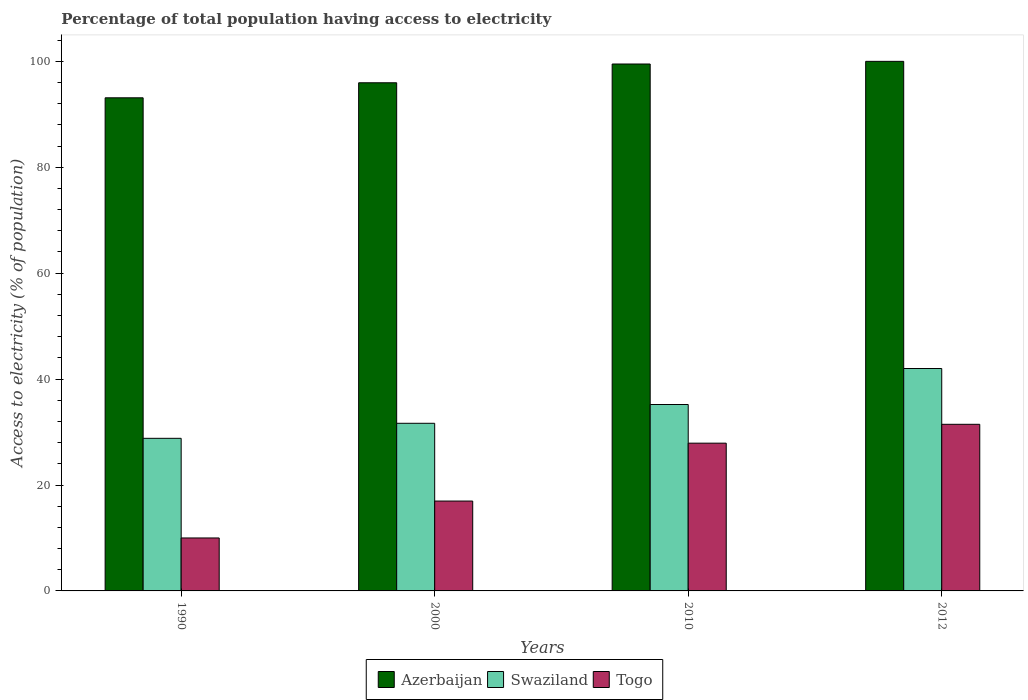How many different coloured bars are there?
Make the answer very short. 3. Are the number of bars on each tick of the X-axis equal?
Offer a terse response. Yes. How many bars are there on the 2nd tick from the right?
Provide a succinct answer. 3. What is the percentage of population that have access to electricity in Swaziland in 1990?
Your response must be concise. 28.82. In which year was the percentage of population that have access to electricity in Swaziland maximum?
Your response must be concise. 2012. What is the total percentage of population that have access to electricity in Azerbaijan in the graph?
Keep it short and to the point. 388.57. What is the difference between the percentage of population that have access to electricity in Swaziland in 1990 and that in 2000?
Make the answer very short. -2.84. What is the difference between the percentage of population that have access to electricity in Azerbaijan in 2012 and the percentage of population that have access to electricity in Swaziland in 1990?
Your response must be concise. 71.18. What is the average percentage of population that have access to electricity in Azerbaijan per year?
Keep it short and to the point. 97.14. In the year 2010, what is the difference between the percentage of population that have access to electricity in Togo and percentage of population that have access to electricity in Swaziland?
Provide a short and direct response. -7.3. What is the ratio of the percentage of population that have access to electricity in Azerbaijan in 1990 to that in 2010?
Your answer should be very brief. 0.94. What is the difference between the highest and the second highest percentage of population that have access to electricity in Swaziland?
Make the answer very short. 6.8. What is the difference between the highest and the lowest percentage of population that have access to electricity in Swaziland?
Offer a very short reply. 13.18. What does the 1st bar from the left in 1990 represents?
Provide a succinct answer. Azerbaijan. What does the 2nd bar from the right in 2010 represents?
Ensure brevity in your answer.  Swaziland. How many years are there in the graph?
Provide a succinct answer. 4. What is the difference between two consecutive major ticks on the Y-axis?
Your answer should be compact. 20. Are the values on the major ticks of Y-axis written in scientific E-notation?
Give a very brief answer. No. Does the graph contain grids?
Your answer should be very brief. No. How many legend labels are there?
Ensure brevity in your answer.  3. What is the title of the graph?
Give a very brief answer. Percentage of total population having access to electricity. What is the label or title of the Y-axis?
Ensure brevity in your answer.  Access to electricity (% of population). What is the Access to electricity (% of population) of Azerbaijan in 1990?
Provide a short and direct response. 93.12. What is the Access to electricity (% of population) in Swaziland in 1990?
Offer a very short reply. 28.82. What is the Access to electricity (% of population) in Togo in 1990?
Offer a very short reply. 10. What is the Access to electricity (% of population) of Azerbaijan in 2000?
Give a very brief answer. 95.96. What is the Access to electricity (% of population) of Swaziland in 2000?
Keep it short and to the point. 31.66. What is the Access to electricity (% of population) in Togo in 2000?
Ensure brevity in your answer.  16.97. What is the Access to electricity (% of population) of Azerbaijan in 2010?
Provide a succinct answer. 99.5. What is the Access to electricity (% of population) in Swaziland in 2010?
Provide a succinct answer. 35.2. What is the Access to electricity (% of population) in Togo in 2010?
Provide a short and direct response. 27.9. What is the Access to electricity (% of population) in Togo in 2012?
Provide a short and direct response. 31.46. Across all years, what is the maximum Access to electricity (% of population) in Swaziland?
Your answer should be compact. 42. Across all years, what is the maximum Access to electricity (% of population) of Togo?
Your answer should be very brief. 31.46. Across all years, what is the minimum Access to electricity (% of population) of Azerbaijan?
Ensure brevity in your answer.  93.12. Across all years, what is the minimum Access to electricity (% of population) in Swaziland?
Offer a very short reply. 28.82. Across all years, what is the minimum Access to electricity (% of population) of Togo?
Provide a succinct answer. 10. What is the total Access to electricity (% of population) of Azerbaijan in the graph?
Ensure brevity in your answer.  388.57. What is the total Access to electricity (% of population) in Swaziland in the graph?
Give a very brief answer. 137.67. What is the total Access to electricity (% of population) of Togo in the graph?
Make the answer very short. 86.33. What is the difference between the Access to electricity (% of population) of Azerbaijan in 1990 and that in 2000?
Your answer should be very brief. -2.84. What is the difference between the Access to electricity (% of population) in Swaziland in 1990 and that in 2000?
Keep it short and to the point. -2.84. What is the difference between the Access to electricity (% of population) in Togo in 1990 and that in 2000?
Your answer should be compact. -6.97. What is the difference between the Access to electricity (% of population) of Azerbaijan in 1990 and that in 2010?
Provide a succinct answer. -6.38. What is the difference between the Access to electricity (% of population) of Swaziland in 1990 and that in 2010?
Keep it short and to the point. -6.38. What is the difference between the Access to electricity (% of population) of Togo in 1990 and that in 2010?
Your answer should be compact. -17.9. What is the difference between the Access to electricity (% of population) in Azerbaijan in 1990 and that in 2012?
Your response must be concise. -6.88. What is the difference between the Access to electricity (% of population) of Swaziland in 1990 and that in 2012?
Provide a succinct answer. -13.18. What is the difference between the Access to electricity (% of population) in Togo in 1990 and that in 2012?
Provide a succinct answer. -21.46. What is the difference between the Access to electricity (% of population) of Azerbaijan in 2000 and that in 2010?
Offer a very short reply. -3.54. What is the difference between the Access to electricity (% of population) in Swaziland in 2000 and that in 2010?
Make the answer very short. -3.54. What is the difference between the Access to electricity (% of population) of Togo in 2000 and that in 2010?
Your answer should be compact. -10.93. What is the difference between the Access to electricity (% of population) in Azerbaijan in 2000 and that in 2012?
Your answer should be very brief. -4.04. What is the difference between the Access to electricity (% of population) of Swaziland in 2000 and that in 2012?
Ensure brevity in your answer.  -10.34. What is the difference between the Access to electricity (% of population) of Togo in 2000 and that in 2012?
Offer a terse response. -14.49. What is the difference between the Access to electricity (% of population) in Togo in 2010 and that in 2012?
Offer a terse response. -3.56. What is the difference between the Access to electricity (% of population) in Azerbaijan in 1990 and the Access to electricity (% of population) in Swaziland in 2000?
Ensure brevity in your answer.  61.46. What is the difference between the Access to electricity (% of population) in Azerbaijan in 1990 and the Access to electricity (% of population) in Togo in 2000?
Ensure brevity in your answer.  76.15. What is the difference between the Access to electricity (% of population) of Swaziland in 1990 and the Access to electricity (% of population) of Togo in 2000?
Make the answer very short. 11.85. What is the difference between the Access to electricity (% of population) of Azerbaijan in 1990 and the Access to electricity (% of population) of Swaziland in 2010?
Offer a terse response. 57.92. What is the difference between the Access to electricity (% of population) of Azerbaijan in 1990 and the Access to electricity (% of population) of Togo in 2010?
Your answer should be very brief. 65.22. What is the difference between the Access to electricity (% of population) in Swaziland in 1990 and the Access to electricity (% of population) in Togo in 2010?
Give a very brief answer. 0.92. What is the difference between the Access to electricity (% of population) in Azerbaijan in 1990 and the Access to electricity (% of population) in Swaziland in 2012?
Provide a succinct answer. 51.12. What is the difference between the Access to electricity (% of population) of Azerbaijan in 1990 and the Access to electricity (% of population) of Togo in 2012?
Give a very brief answer. 61.65. What is the difference between the Access to electricity (% of population) of Swaziland in 1990 and the Access to electricity (% of population) of Togo in 2012?
Give a very brief answer. -2.65. What is the difference between the Access to electricity (% of population) of Azerbaijan in 2000 and the Access to electricity (% of population) of Swaziland in 2010?
Keep it short and to the point. 60.76. What is the difference between the Access to electricity (% of population) of Azerbaijan in 2000 and the Access to electricity (% of population) of Togo in 2010?
Your response must be concise. 68.06. What is the difference between the Access to electricity (% of population) of Swaziland in 2000 and the Access to electricity (% of population) of Togo in 2010?
Provide a short and direct response. 3.76. What is the difference between the Access to electricity (% of population) in Azerbaijan in 2000 and the Access to electricity (% of population) in Swaziland in 2012?
Ensure brevity in your answer.  53.96. What is the difference between the Access to electricity (% of population) of Azerbaijan in 2000 and the Access to electricity (% of population) of Togo in 2012?
Ensure brevity in your answer.  64.49. What is the difference between the Access to electricity (% of population) of Swaziland in 2000 and the Access to electricity (% of population) of Togo in 2012?
Keep it short and to the point. 0.19. What is the difference between the Access to electricity (% of population) of Azerbaijan in 2010 and the Access to electricity (% of population) of Swaziland in 2012?
Offer a terse response. 57.5. What is the difference between the Access to electricity (% of population) of Azerbaijan in 2010 and the Access to electricity (% of population) of Togo in 2012?
Provide a succinct answer. 68.04. What is the difference between the Access to electricity (% of population) of Swaziland in 2010 and the Access to electricity (% of population) of Togo in 2012?
Keep it short and to the point. 3.74. What is the average Access to electricity (% of population) of Azerbaijan per year?
Offer a terse response. 97.14. What is the average Access to electricity (% of population) in Swaziland per year?
Ensure brevity in your answer.  34.42. What is the average Access to electricity (% of population) in Togo per year?
Provide a succinct answer. 21.58. In the year 1990, what is the difference between the Access to electricity (% of population) of Azerbaijan and Access to electricity (% of population) of Swaziland?
Keep it short and to the point. 64.3. In the year 1990, what is the difference between the Access to electricity (% of population) of Azerbaijan and Access to electricity (% of population) of Togo?
Give a very brief answer. 83.12. In the year 1990, what is the difference between the Access to electricity (% of population) in Swaziland and Access to electricity (% of population) in Togo?
Your response must be concise. 18.82. In the year 2000, what is the difference between the Access to electricity (% of population) in Azerbaijan and Access to electricity (% of population) in Swaziland?
Your response must be concise. 64.3. In the year 2000, what is the difference between the Access to electricity (% of population) of Azerbaijan and Access to electricity (% of population) of Togo?
Provide a short and direct response. 78.99. In the year 2000, what is the difference between the Access to electricity (% of population) in Swaziland and Access to electricity (% of population) in Togo?
Give a very brief answer. 14.69. In the year 2010, what is the difference between the Access to electricity (% of population) of Azerbaijan and Access to electricity (% of population) of Swaziland?
Offer a very short reply. 64.3. In the year 2010, what is the difference between the Access to electricity (% of population) of Azerbaijan and Access to electricity (% of population) of Togo?
Your answer should be compact. 71.6. In the year 2010, what is the difference between the Access to electricity (% of population) of Swaziland and Access to electricity (% of population) of Togo?
Provide a succinct answer. 7.3. In the year 2012, what is the difference between the Access to electricity (% of population) in Azerbaijan and Access to electricity (% of population) in Swaziland?
Give a very brief answer. 58. In the year 2012, what is the difference between the Access to electricity (% of population) of Azerbaijan and Access to electricity (% of population) of Togo?
Your response must be concise. 68.54. In the year 2012, what is the difference between the Access to electricity (% of population) of Swaziland and Access to electricity (% of population) of Togo?
Offer a very short reply. 10.54. What is the ratio of the Access to electricity (% of population) of Azerbaijan in 1990 to that in 2000?
Make the answer very short. 0.97. What is the ratio of the Access to electricity (% of population) in Swaziland in 1990 to that in 2000?
Offer a very short reply. 0.91. What is the ratio of the Access to electricity (% of population) in Togo in 1990 to that in 2000?
Ensure brevity in your answer.  0.59. What is the ratio of the Access to electricity (% of population) of Azerbaijan in 1990 to that in 2010?
Your response must be concise. 0.94. What is the ratio of the Access to electricity (% of population) in Swaziland in 1990 to that in 2010?
Make the answer very short. 0.82. What is the ratio of the Access to electricity (% of population) in Togo in 1990 to that in 2010?
Offer a very short reply. 0.36. What is the ratio of the Access to electricity (% of population) of Azerbaijan in 1990 to that in 2012?
Offer a very short reply. 0.93. What is the ratio of the Access to electricity (% of population) in Swaziland in 1990 to that in 2012?
Provide a succinct answer. 0.69. What is the ratio of the Access to electricity (% of population) of Togo in 1990 to that in 2012?
Offer a very short reply. 0.32. What is the ratio of the Access to electricity (% of population) in Azerbaijan in 2000 to that in 2010?
Provide a succinct answer. 0.96. What is the ratio of the Access to electricity (% of population) of Swaziland in 2000 to that in 2010?
Offer a very short reply. 0.9. What is the ratio of the Access to electricity (% of population) in Togo in 2000 to that in 2010?
Keep it short and to the point. 0.61. What is the ratio of the Access to electricity (% of population) in Azerbaijan in 2000 to that in 2012?
Provide a short and direct response. 0.96. What is the ratio of the Access to electricity (% of population) in Swaziland in 2000 to that in 2012?
Make the answer very short. 0.75. What is the ratio of the Access to electricity (% of population) in Togo in 2000 to that in 2012?
Keep it short and to the point. 0.54. What is the ratio of the Access to electricity (% of population) of Azerbaijan in 2010 to that in 2012?
Ensure brevity in your answer.  0.99. What is the ratio of the Access to electricity (% of population) of Swaziland in 2010 to that in 2012?
Your answer should be compact. 0.84. What is the ratio of the Access to electricity (% of population) in Togo in 2010 to that in 2012?
Keep it short and to the point. 0.89. What is the difference between the highest and the second highest Access to electricity (% of population) of Swaziland?
Your response must be concise. 6.8. What is the difference between the highest and the second highest Access to electricity (% of population) in Togo?
Offer a very short reply. 3.56. What is the difference between the highest and the lowest Access to electricity (% of population) in Azerbaijan?
Provide a succinct answer. 6.88. What is the difference between the highest and the lowest Access to electricity (% of population) in Swaziland?
Make the answer very short. 13.18. What is the difference between the highest and the lowest Access to electricity (% of population) in Togo?
Offer a very short reply. 21.46. 